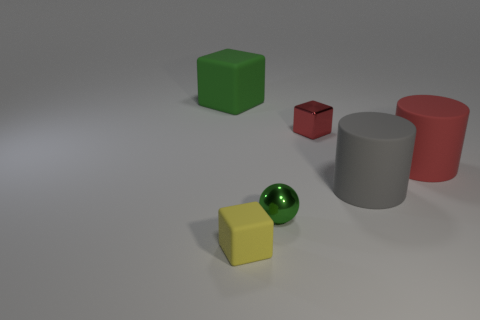There is a green thing that is on the left side of the tiny matte object; how many red cubes are on the right side of it?
Your answer should be compact. 1. What color is the other matte object that is the same shape as the large green matte thing?
Offer a terse response. Yellow. Do the small sphere and the large gray cylinder have the same material?
Ensure brevity in your answer.  No. How many blocks are either red things or large shiny objects?
Keep it short and to the point. 1. There is a red object that is on the right side of the metal object that is behind the red matte object behind the small yellow thing; how big is it?
Provide a succinct answer. Large. There is a yellow matte thing that is the same shape as the large green rubber thing; what size is it?
Keep it short and to the point. Small. What number of small metallic spheres are right of the green rubber thing?
Keep it short and to the point. 1. There is a big object to the left of the yellow matte object; is it the same color as the sphere?
Ensure brevity in your answer.  Yes. What number of gray things are big matte balls or large matte objects?
Make the answer very short. 1. What color is the cube on the left side of the block that is in front of the green ball?
Your answer should be very brief. Green. 